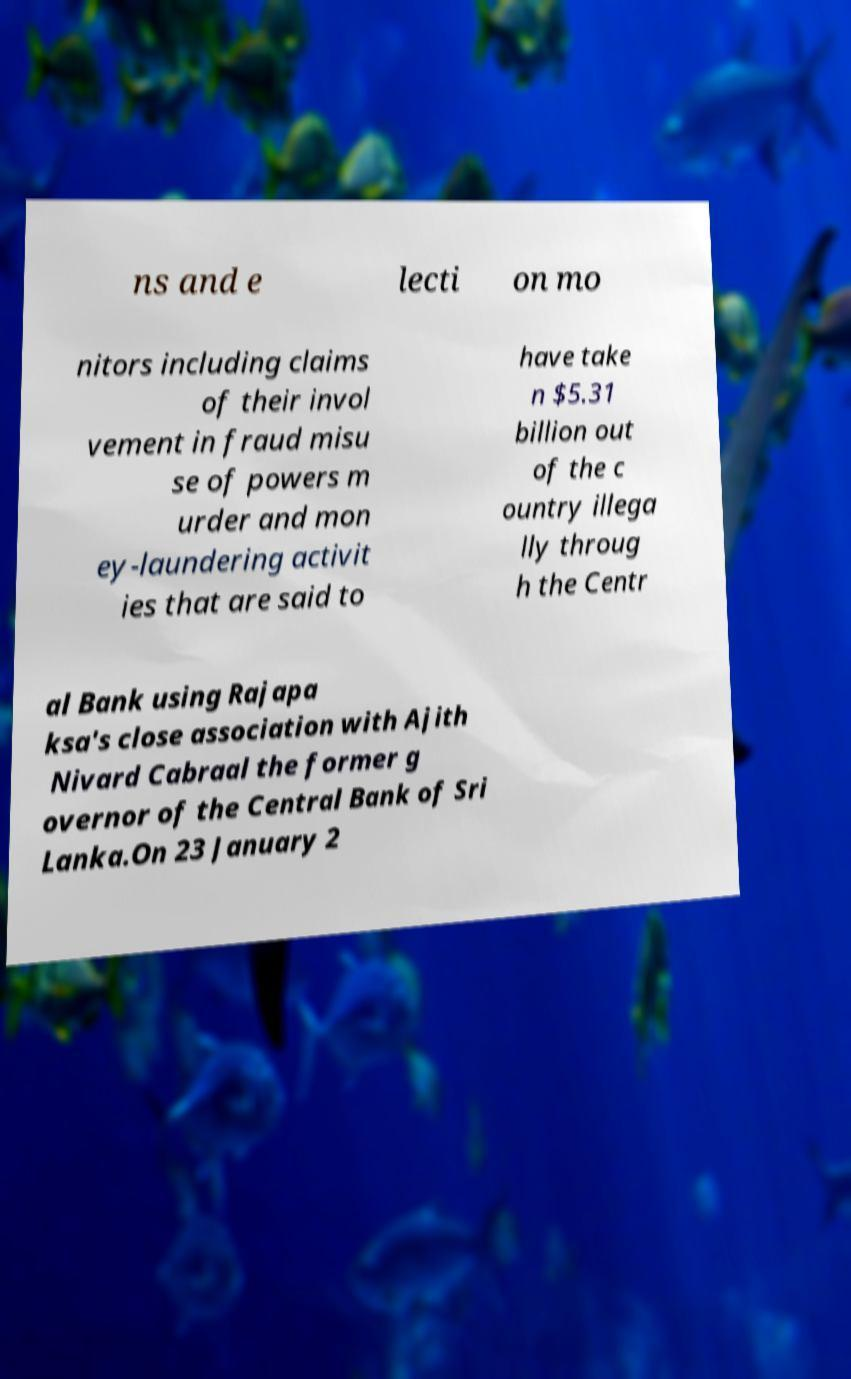I need the written content from this picture converted into text. Can you do that? ns and e lecti on mo nitors including claims of their invol vement in fraud misu se of powers m urder and mon ey-laundering activit ies that are said to have take n $5.31 billion out of the c ountry illega lly throug h the Centr al Bank using Rajapa ksa's close association with Ajith Nivard Cabraal the former g overnor of the Central Bank of Sri Lanka.On 23 January 2 